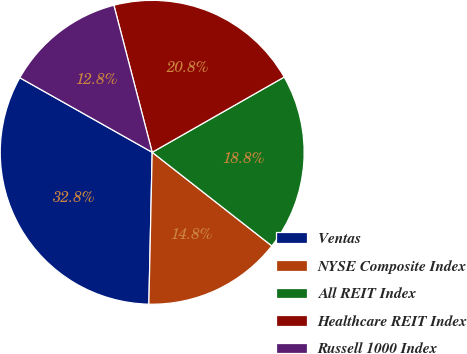Convert chart to OTSL. <chart><loc_0><loc_0><loc_500><loc_500><pie_chart><fcel>Ventas<fcel>NYSE Composite Index<fcel>All REIT Index<fcel>Healthcare REIT Index<fcel>Russell 1000 Index<nl><fcel>32.81%<fcel>14.78%<fcel>18.81%<fcel>20.81%<fcel>12.78%<nl></chart> 